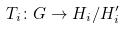<formula> <loc_0><loc_0><loc_500><loc_500>T _ { i } \colon G \rightarrow H _ { i } / H _ { i } ^ { \prime }</formula> 